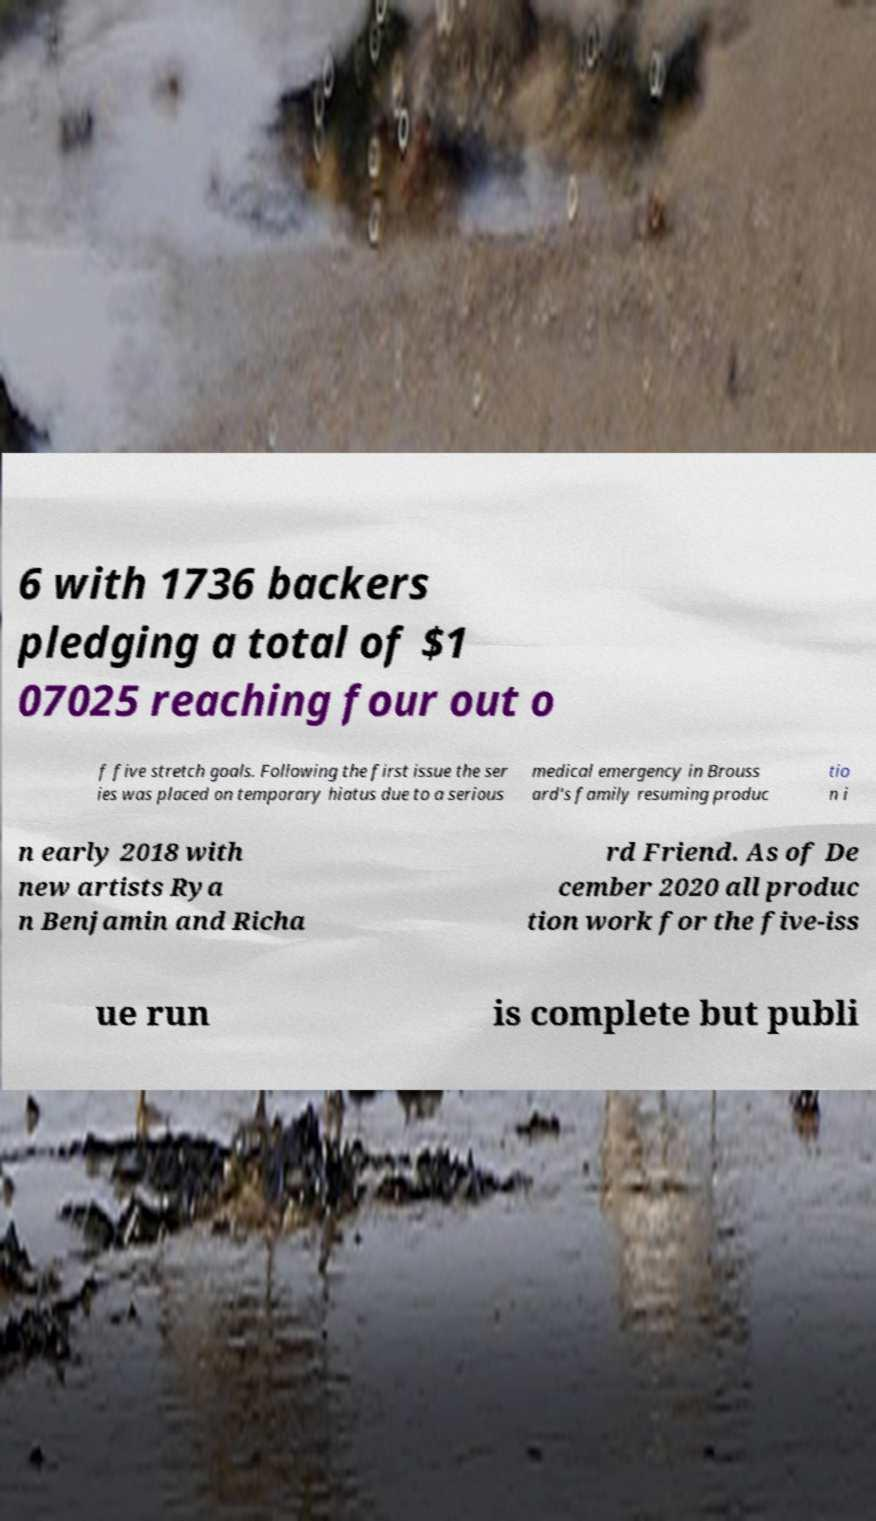Please identify and transcribe the text found in this image. 6 with 1736 backers pledging a total of $1 07025 reaching four out o f five stretch goals. Following the first issue the ser ies was placed on temporary hiatus due to a serious medical emergency in Brouss ard's family resuming produc tio n i n early 2018 with new artists Rya n Benjamin and Richa rd Friend. As of De cember 2020 all produc tion work for the five-iss ue run is complete but publi 